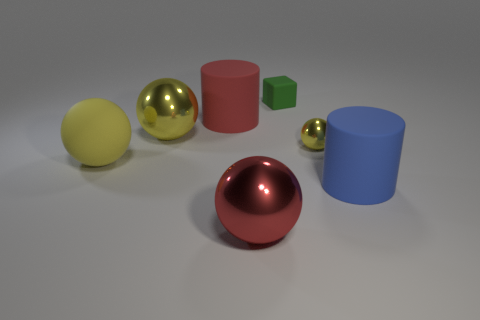How many yellow balls must be subtracted to get 1 yellow balls? 2 Subtract all big spheres. How many spheres are left? 1 Subtract all red cubes. How many green cylinders are left? 0 Add 2 brown rubber balls. How many objects exist? 9 Subtract all blue cylinders. How many cylinders are left? 1 Add 3 big red objects. How many big red objects exist? 5 Subtract 0 gray cubes. How many objects are left? 7 Subtract all cylinders. How many objects are left? 5 Subtract all red cylinders. Subtract all green cubes. How many cylinders are left? 1 Subtract all blue matte cylinders. Subtract all small metal balls. How many objects are left? 5 